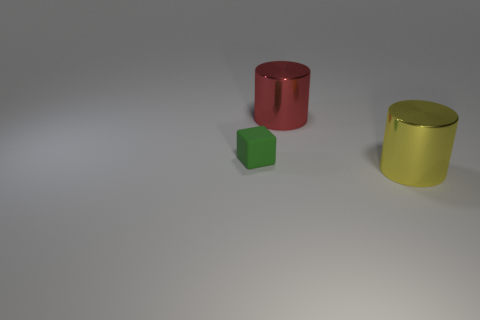Add 2 red shiny things. How many objects exist? 5 Subtract all blocks. How many objects are left? 2 Add 2 green matte things. How many green matte things exist? 3 Subtract 0 green cylinders. How many objects are left? 3 Subtract all big red matte cylinders. Subtract all large red metal objects. How many objects are left? 2 Add 2 big yellow metallic cylinders. How many big yellow metallic cylinders are left? 3 